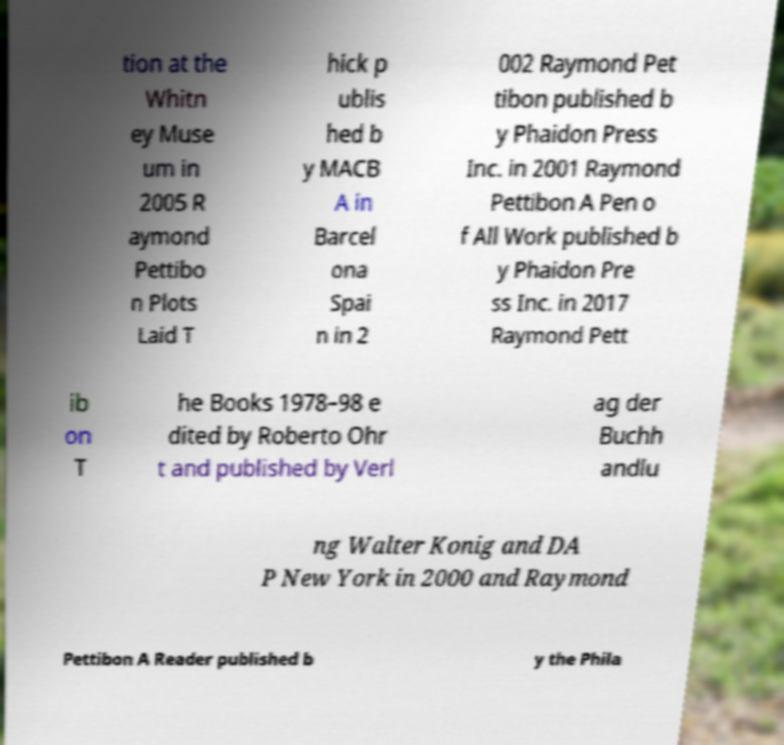Please identify and transcribe the text found in this image. tion at the Whitn ey Muse um in 2005 R aymond Pettibo n Plots Laid T hick p ublis hed b y MACB A in Barcel ona Spai n in 2 002 Raymond Pet tibon published b y Phaidon Press Inc. in 2001 Raymond Pettibon A Pen o f All Work published b y Phaidon Pre ss Inc. in 2017 Raymond Pett ib on T he Books 1978–98 e dited by Roberto Ohr t and published by Verl ag der Buchh andlu ng Walter Konig and DA P New York in 2000 and Raymond Pettibon A Reader published b y the Phila 